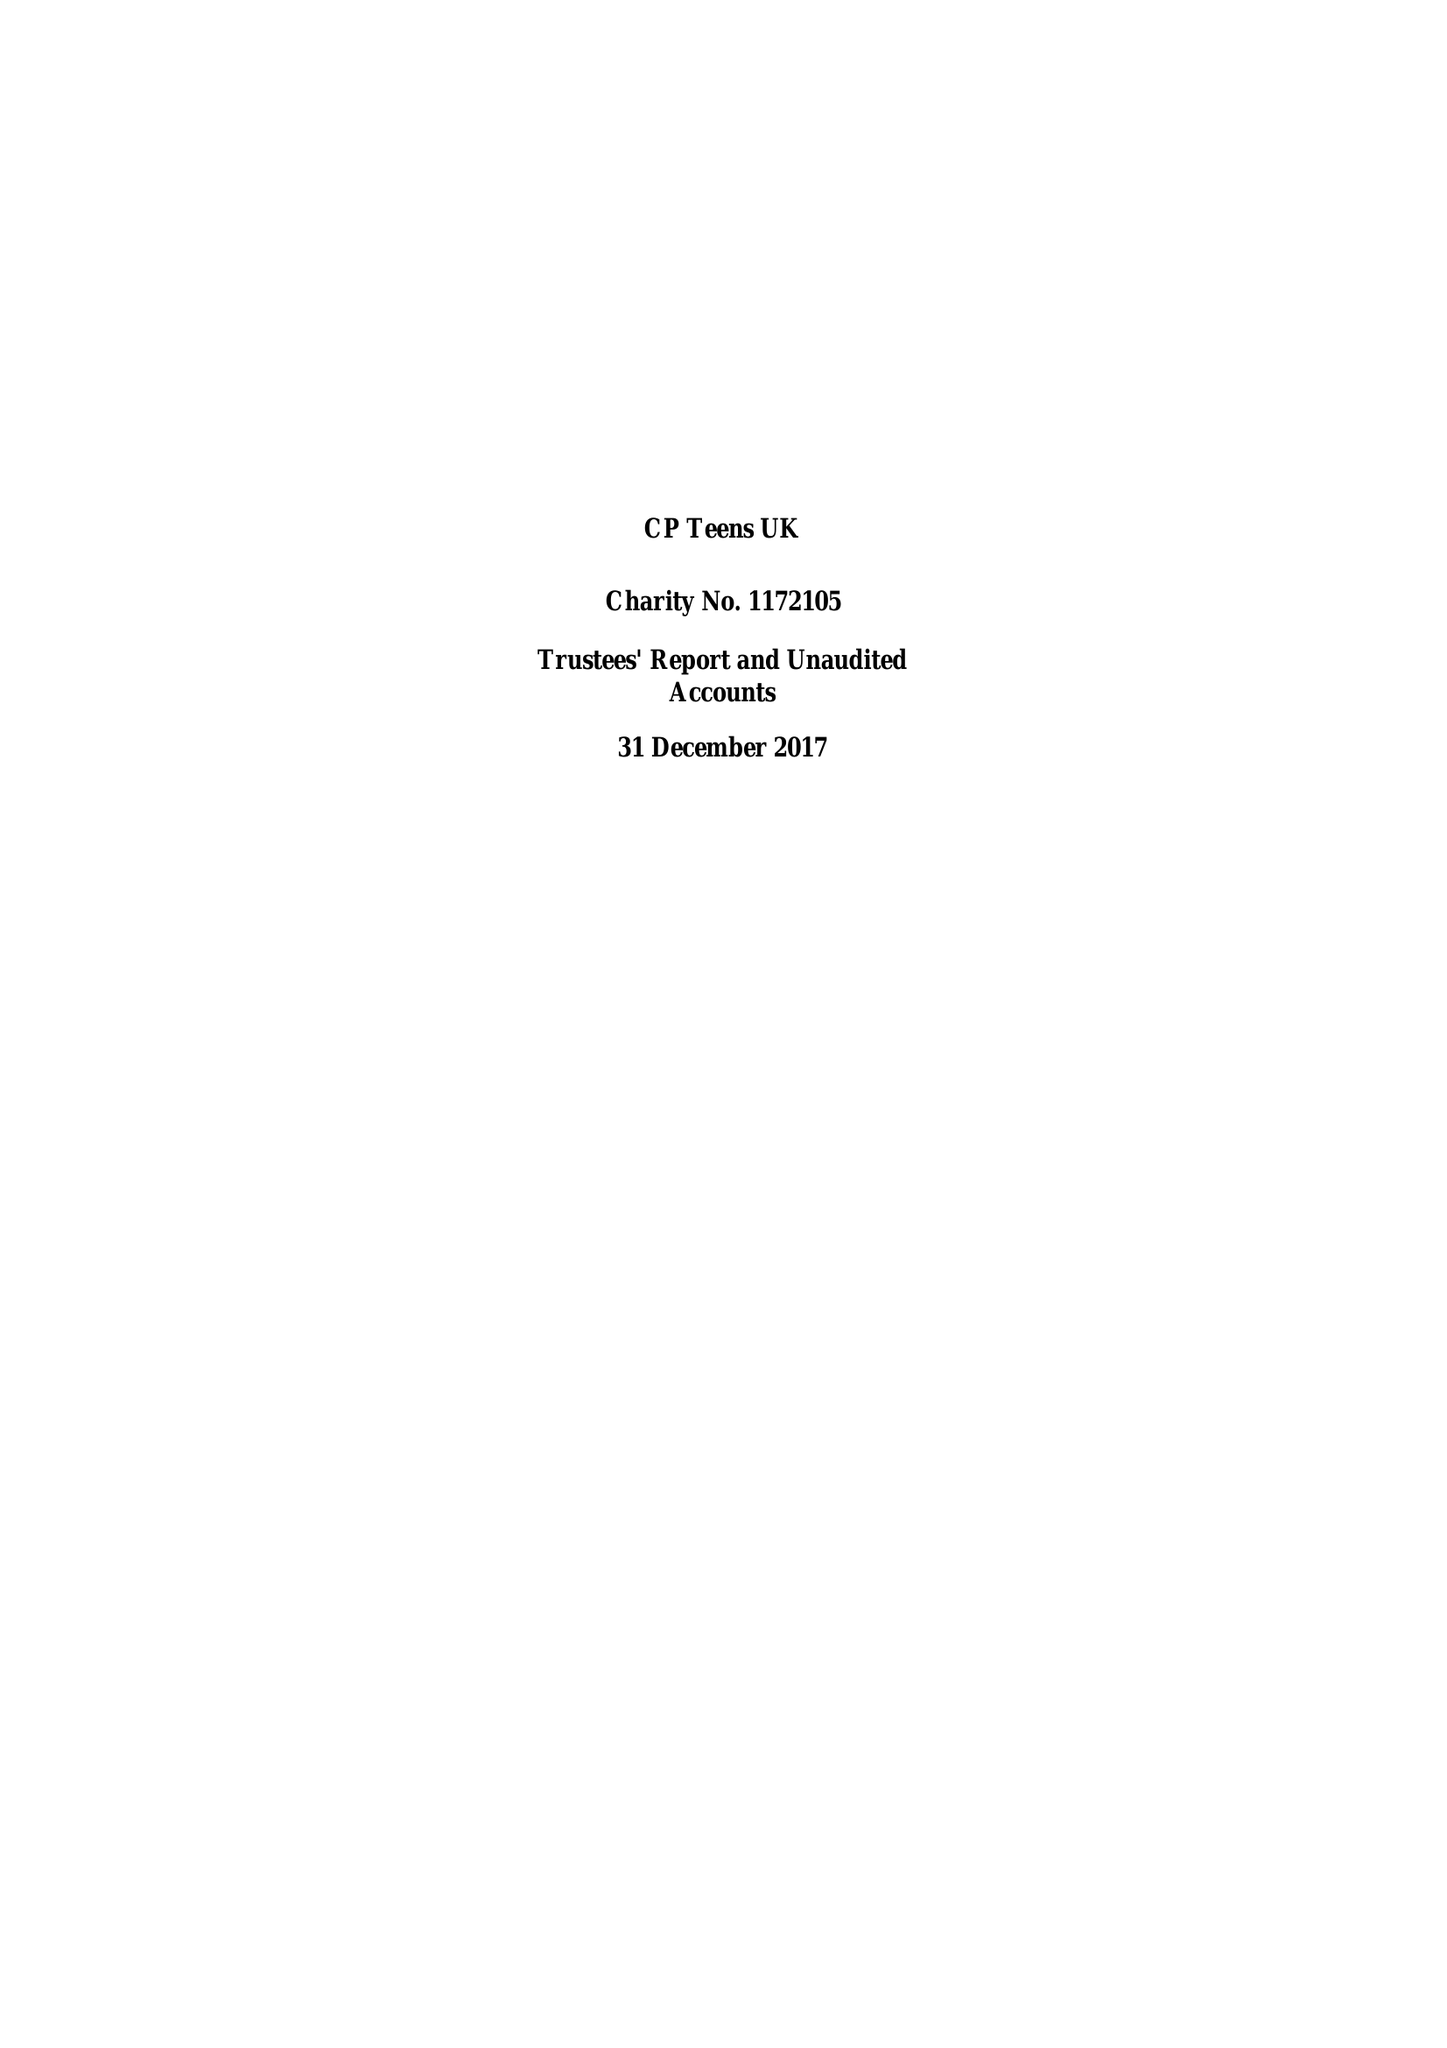What is the value for the charity_number?
Answer the question using a single word or phrase. 1172105 